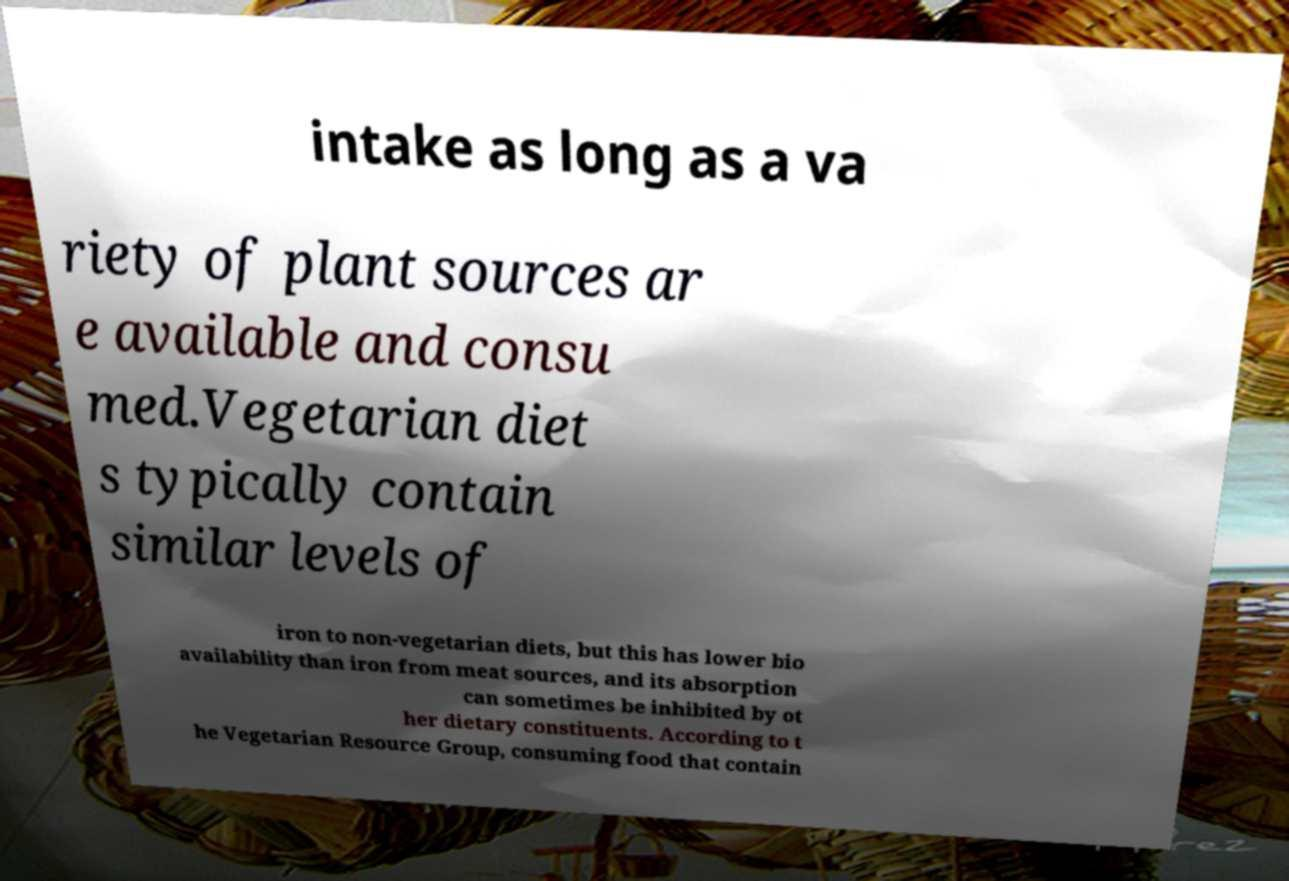Please read and relay the text visible in this image. What does it say? intake as long as a va riety of plant sources ar e available and consu med.Vegetarian diet s typically contain similar levels of iron to non-vegetarian diets, but this has lower bio availability than iron from meat sources, and its absorption can sometimes be inhibited by ot her dietary constituents. According to t he Vegetarian Resource Group, consuming food that contain 